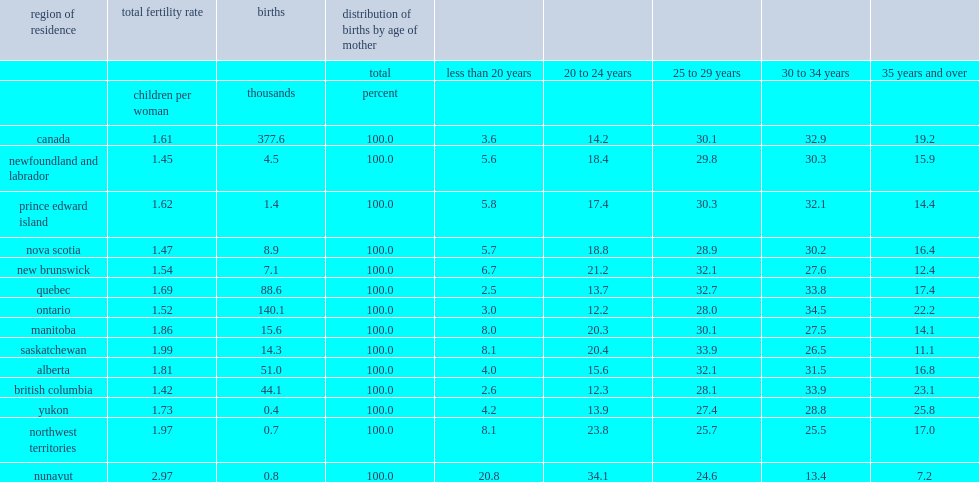What was the total fertility rate in found in nunavut? 2.97. 